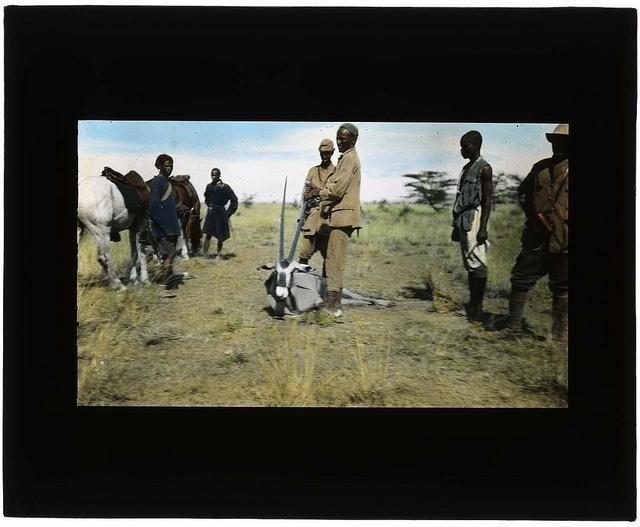How many horses are there?
Give a very brief answer. 2. How many people can be seen?
Give a very brief answer. 6. 